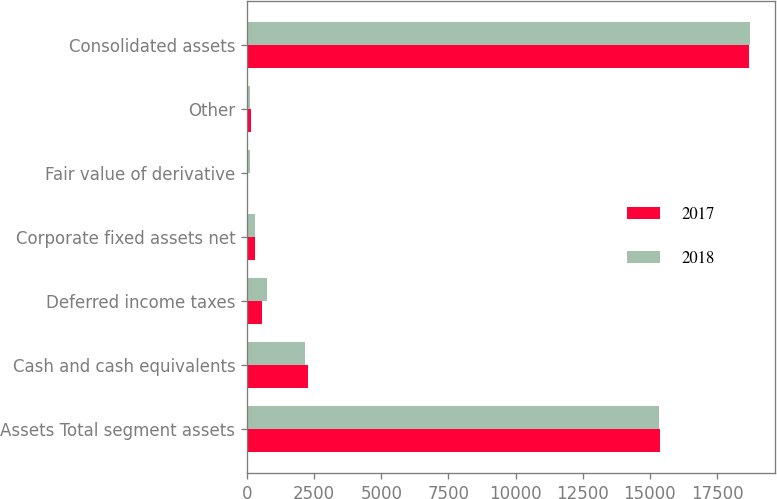Convert chart to OTSL. <chart><loc_0><loc_0><loc_500><loc_500><stacked_bar_chart><ecel><fcel>Assets Total segment assets<fcel>Cash and cash equivalents<fcel>Deferred income taxes<fcel>Corporate fixed assets net<fcel>Fair value of derivative<fcel>Other<fcel>Consolidated assets<nl><fcel>2017<fcel>15369<fcel>2277<fcel>573<fcel>305<fcel>37<fcel>132<fcel>18693<nl><fcel>2018<fcel>15321<fcel>2150<fcel>743<fcel>310<fcel>91<fcel>103<fcel>18718<nl></chart> 